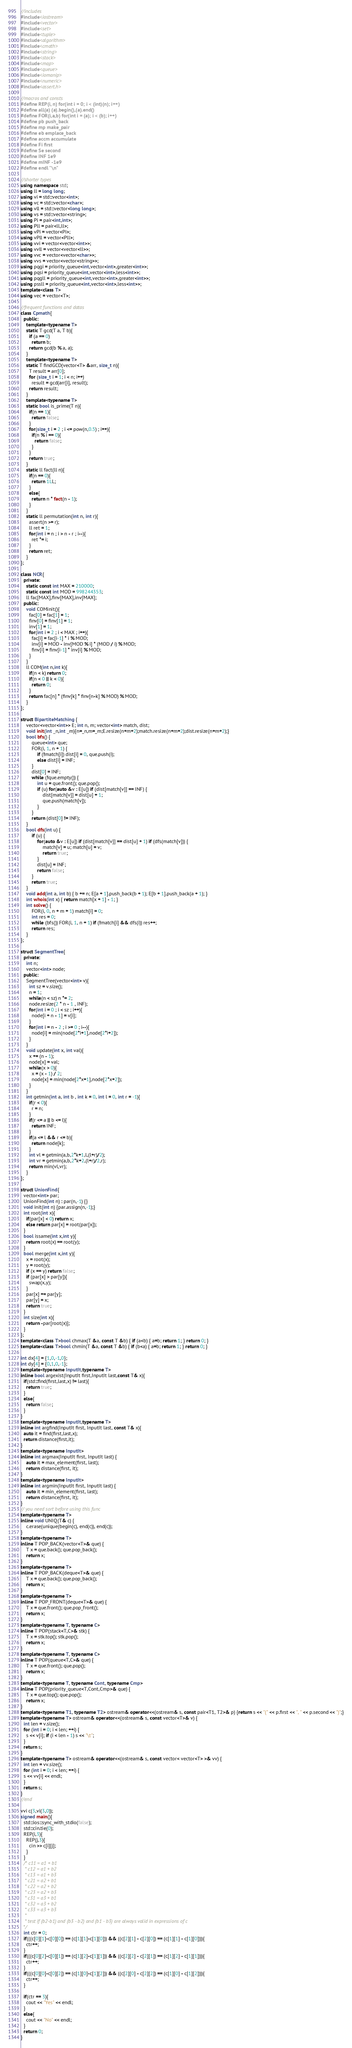<code> <loc_0><loc_0><loc_500><loc_500><_C++_>//includes
#include<iostream>
#include<vector>
#include<set>
#include<tuple>
#include<algorithm>
#include<cmath>
#include<string>
#include<stack>
#include<map>
#include<queue>
#include<iomanip>
#include<numeric>
#include<assert.h>

//macros and consts
#define REP(i, n) for(int i = 0; i < (int)(n); i++)
#define all(a) (a).begin(),(a).end()
#define FOR(i,a,b) for(int i = (a); i < (b); i++)
#define pb push_back
#define mp make_pair
#define eb emplace_back
#define accm accumulate
#define Fi first
#define Se second
#define INF 1e9
#define mINF -1e9
#define endl "\n"

//shorter types
using namespace std;
using ll = long long;
using vi = std::vector<int>;
using vc = std::vector<char>;
using vll = std::vector<long long>;
using vs = std::vector<string>;
using Pi = pair<int,int>;
using Pll = pair<ll,ll>;
using vPi = vector<Pi>;
using vPll = vector<Pll>;
using vvi = vector<vector<int>>;
using vvll = vector<vector<ll>>;
using vvc = vector<vector<char>>;
using vvs = vector<vector<string>>;
using pqgi = priority_queue<int,vector<int>,greater<int>>;
using pqsi = priority_queue<int,vector<int>,less<int>>;
using pqgll = priority_queue<int,vector<int>,greater<int>>;
using pssll = priority_queue<int,vector<int>,less<int>>;
template<class T>
using vec = vector<T>;

//frequent functions and datas
class Cpmath{
  public:
    template<typename T>
    static T gcd(T a, T b){
      if (a == 0) 
        return b; 
      return gcd(b % a, a); 
    }
    template<typename T>
    static T findGCD(vector<T> &arr, size_t n){
      T result = arr[0]; 
      for (size_t i = 1; i < n; i++) 
        result = gcd(arr[i], result); 
      return result; 
    }
    template<typename T>
    static bool is_prime(T n){
      if(n == 1){
        return false;
      }
      for(size_t i = 2 ; i <= pow(n,0.5) ; i++){
        if(n % i == 0){
          return false;
        }
      }
      return true;
    }
    static ll fact(ll n){
      if(n == 0){
        return 1LL;
      }
      else{
        return n * fact(n - 1);
      }
    }
    static ll permutation(int n, int r){
      assert(n >= r);
      ll ret = 1;
      for(int i = n ; i > n - r ; i--){
        ret *= i;
      }
      return ret;
    }
};

class NCR{
  private:
    static const int MAX = 210000;
    static const int MOD = 998244353;
    ll fac[MAX],finv[MAX],inv[MAX];
  public:
    void COMinit(){
      fac[0] = fac[1] = 1;
      finv[0] = finv[1] = 1;
      inv[1] = 1;
      for(int i = 2 ; i < MAX ; i++){
        fac[i] = fac[i-1] * i % MOD;
        inv[i] = MOD - inv[MOD % i] * (MOD / i) % MOD;
        finv[i] = finv[i-1] * inv[i] % MOD;
      }
    }
    ll COM(int n,int k){
      if(n < k) return 0;
      if(n < 0 || k < 0){
        return 0;
      }
      return fac[n] * (finv[k] * finv[n-k] % MOD) % MOD;
    }
};

struct BipartiteMatching {
    vector<vector<int>> E; int n, m; vector<int> match, dist;
    void init(int _n,int _m){n=_n,m=_m;E.resize(n+m+2);match.resize(n+m+2);dist.resize(n+m+2);}
    bool bfs() {
        queue<int> que;
        FOR(i, 1, n + 1) {
            if (!match[i]) dist[i] = 0, que.push(i);
            else dist[i] = INF;
        }
        dist[0] = INF;
        while (!que.empty()) {
            int u = que.front(); que.pop();
            if (u) for(auto &v : E[u]) if (dist[match[v]] == INF) {
                dist[match[v]] = dist[u] + 1;
                que.push(match[v]);
            }
        }
        return (dist[0] != INF);
    }
    bool dfs(int u) {
        if (u) {
            for(auto &v : E[u]) if (dist[match[v]] == dist[u] + 1) if (dfs(match[v])) {
                match[v] = u; match[u] = v;
                return true;
            }
            dist[u] = INF;
            return false;
        }
        return true;
    }
    void add(int a, int b) { b += n; E[a + 1].push_back(b + 1); E[b + 1].push_back(a + 1); }
    int whois(int x) { return match[x + 1] - 1; }
    int solve() {
        FOR(i, 0, n + m + 1) match[i] = 0;
        int res = 0;
        while (bfs()) FOR(i, 1, n + 1) if (!match[i] && dfs(i)) res++;
        return res;
    }
};

struct SegmentTree{
  private:
    int n;
    vector<int> node;
  public:
    SegmentTree(vector<int> v){
      int sz = v.size();
      n = 1;
      while(n < sz) n *= 2;
      node.resize(2 * n - 1 , INF);
      for(int i = 0 ; i < sz ; i++){
        node[i + n - 1] = v[i];
      }
      for(int i = n - 2 ; i >= 0 ; i--){
        node[i] = min(node[2*i+1],node[2*i+2]);
      }
    }
    void update(int x, int val){
      x += (n - 1);
      node[x] = val;
      while(x > 0){
        x = (x - 1) / 2;
        node[x] = min(node[2*x+1],node[2*x+2]);
      }
    }
    int getmin(int a, int b , int k = 0, int l = 0, int r = -1){
      if(r < 0){
        r = n;
      }
      if(r <= a || b <= l){
        return INF;
      }
      if(a <= l && r <= b){
        return node[k];
      }
      int vl = getmin(a,b,2*k+1,l,(l+r)/2);
      int vr = getmin(a,b,2*k+2,(l+r)/2,r);
      return min(vl,vr);
    }
};

struct UnionFind{
  vector<int> par;
  UnionFind(int n) : par(n,-1) {}
  void init(int n) {par.assign(n,-1);}
  int root(int x){
    if(par[x] < 0) return x;
    else return par[x] = root(par[x]);
  }
  bool issame(int x,int y){
    return root(x) == root(y);
  }
  bool merge(int x,int y){
    x = root(x);
    y = root(y);
    if (x == y) return false;
    if (par[x] > par[y]){
      swap(x,y);
    }
    par[x] += par[y];
    par[y] = x;
    return true;
  }
  int size(int x){
    return -par[root(x)];
  }
};
template<class T>bool chmax(T &a, const T &b) { if (a<b) { a=b; return 1; } return 0; }
template<class T>bool chmin(T &a, const T &b) { if (b<a) { a=b; return 1; } return 0; }

int dx[4] = {1,0,-1,0};
int dy[4] = {0,1,0,-1};
template<typename InputIt,typename T>
inline bool argexist(InputIt first,InputIt last,const T& x){
  if(std::find(first,last,x) != last){
    return true;
  }
  else{
    return false;
  }
}
template<typename InputIt,typename T>
inline int argfind(InputIt first, InputIt last, const T& x){
  auto it = find(first,last,x);
  return distance(first,it);
}
template<typename InputIt>
inline int argmax(InputIt first, InputIt last) {
    auto it = max_element(first, last);
    return distance(first, it);
}
template<typename InputIt>
inline int argmin(InputIt first, InputIt last) {
    auto it = min_element(first, last);
    return distance(first, it);
}
// you need sort before using this func
template<typename T>
inline void UNIQ(T& c) {
    c.erase(unique(begin(c), end(c)), end(c));
}
template<typename T>
inline T POP_BACK(vector<T>& que) {
    T x = que.back(); que.pop_back();
    return x;
}
template<typename T>
inline T POP_BACK(deque<T>& que) {
    T x = que.back(); que.pop_back();
    return x;
}
template<typename T>
inline T POP_FRONT(deque<T>& que) {
    T x = que.front(); que.pop_front();
    return x;
}
template<typename T, typename C>
inline T POP(stack<T,C>& stk) {
    T x = stk.top(); stk.pop();
    return x;
}
template<typename T, typename C>
inline T POP(queue<T,C>& que) {
    T x = que.front(); que.pop();
    return x;
}
template<typename T, typename Cont, typename Cmp>
inline T POP(priority_queue<T,Cont,Cmp>& que) {
    T x = que.top(); que.pop();
    return x;
}
template<typename T1, typename T2> ostream& operator<<(ostream& s, const pair<T1, T2>& p) {return s << "(" << p.first << ", " << p.second << ")";}
template<typename T> ostream& operator<<(ostream& s, const vector<T>& v) {
  int len = v.size();
  for (int i = 0; i < len; ++i) {
    s << v[i]; if (i < len - 1) s << "\t";
  }
  return s;
}
template<typename T> ostream& operator<<(ostream& s, const vector< vector<T> >& vv) {
  int len = vv.size();
  for (int i = 0; i < len; ++i) {
  s << vv[i] << endl;
  }
  return s;
}
//end

vvi c(3,vi(3,0));
signed main(){
  std::ios::sync_with_stdio(false);
  std::cin.tie(0);
  REP(i,3){
    REP(j,3){
      cin >> c[i][j];
    }
  }
  /* c11 = a1 + b1
   * c12 = a1 + b2
   * c13 = a1 + b3
   * c21 = a2 + b1
   * c22 = a2 + b2
   * c23 = a2 + b3
   * c31 = a3 + b1
   * c32 = a3 + b2
   * c33 = a3 + b3
   *
   * test if (b2-b1) and (b3 - b2) and (b1 - b3) are always valid in expressions of c
  */
  int ctr = 0;
  if(((c[0][1]-c[0][0]) == (c[1][1]-c[1][0])) && ((c[2][1] - c[2][0]) == (c[1][1] - c[1][0]))){
    ctr++;
  }
  if(((c[0][2]-c[0][1]) == (c[1][2]-c[1][1])) && ((c[2][2] - c[2][1]) == (c[1][2] - c[1][1]))){
    ctr++;
  }
  if(((c[0][0]-c[0][2]) == (c[1][0]-c[1][2])) && ((c[2][0] - c[2][2]) == (c[1][0] - c[1][2]))){
    ctr++;
  }

  if(ctr == 3){
    cout << "Yes" << endl;
  }
  else{
    cout << "No" << endl;
  }
  return 0;
}
</code> 